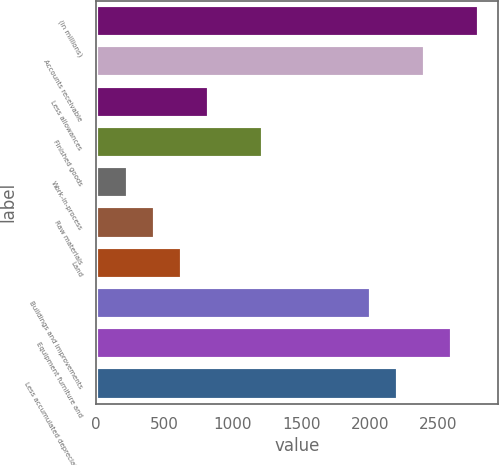Convert chart. <chart><loc_0><loc_0><loc_500><loc_500><bar_chart><fcel>(in millions)<fcel>Accounts receivable<fcel>Less allowances<fcel>Finished goods<fcel>Work-in-process<fcel>Raw materials<fcel>Land<fcel>Buildings and improvements<fcel>Equipment furniture and<fcel>Less accumulated depreciation<nl><fcel>2793<fcel>2399<fcel>823<fcel>1217<fcel>232<fcel>429<fcel>626<fcel>2005<fcel>2596<fcel>2202<nl></chart> 